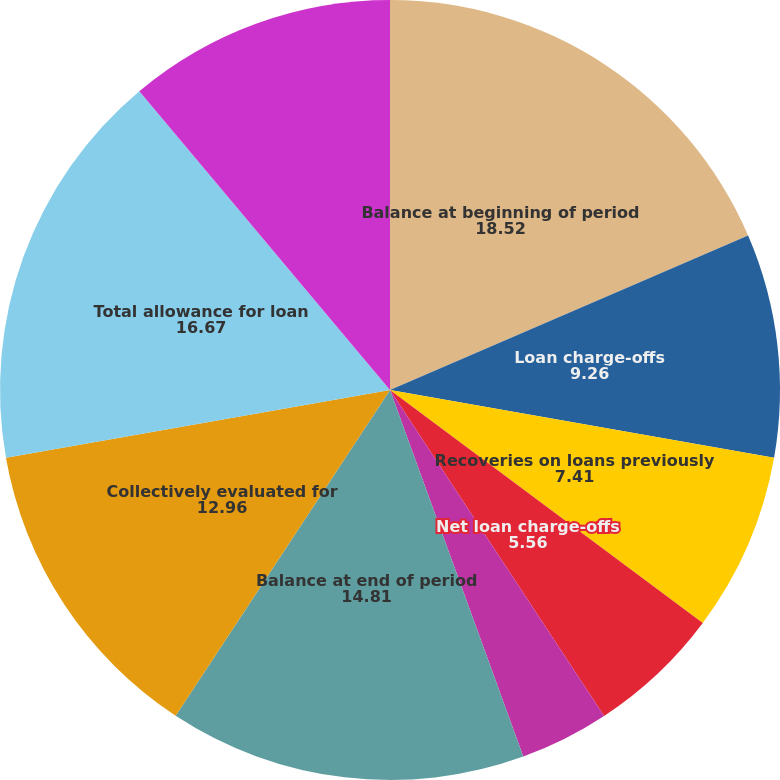Convert chart to OTSL. <chart><loc_0><loc_0><loc_500><loc_500><pie_chart><fcel>Balance at beginning of period<fcel>Loan charge-offs<fcel>Recoveries on loans previously<fcel>Net loan charge-offs<fcel>Provision for loan losses<fcel>Balance at end of period<fcel>As a percentage of total loans<fcel>Collectively evaluated for<fcel>Total allowance for loan<fcel>Individually evaluated for<nl><fcel>18.52%<fcel>9.26%<fcel>7.41%<fcel>5.56%<fcel>3.7%<fcel>14.81%<fcel>0.0%<fcel>12.96%<fcel>16.67%<fcel>11.11%<nl></chart> 